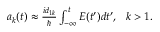<formula> <loc_0><loc_0><loc_500><loc_500>\begin{array} { r } { a _ { k } ( t ) \approx \frac { i d _ { 1 k } } { } \int _ { - \infty } ^ { t } E ( t ^ { \prime } ) d t ^ { \prime } , \ \ k > 1 . } \end{array}</formula> 